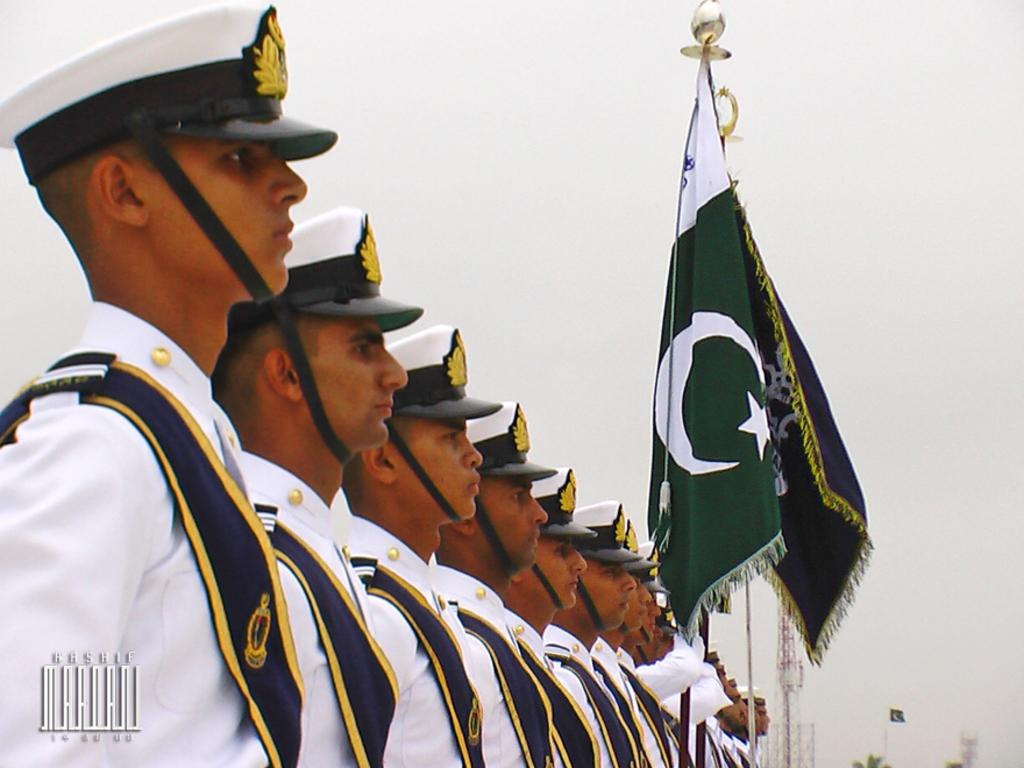What can be seen in the image regarding people? There are people standing in the image. What are the people wearing? The people are wearing uniforms. Are there any other objects or symbols in the image? Yes, there are flags and a tower in the image. What is the color of the sky in the image? The sky appears to be white in color. What type of reward is being given to the brain in the image? There is no brain or reward present in the image. Is there a van visible in the image? No, there is no van present in the image. 